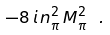Convert formula to latex. <formula><loc_0><loc_0><loc_500><loc_500>- 8 \, i \, n _ { \pi } ^ { 2 } \, M _ { \pi } ^ { 2 } \ .</formula> 